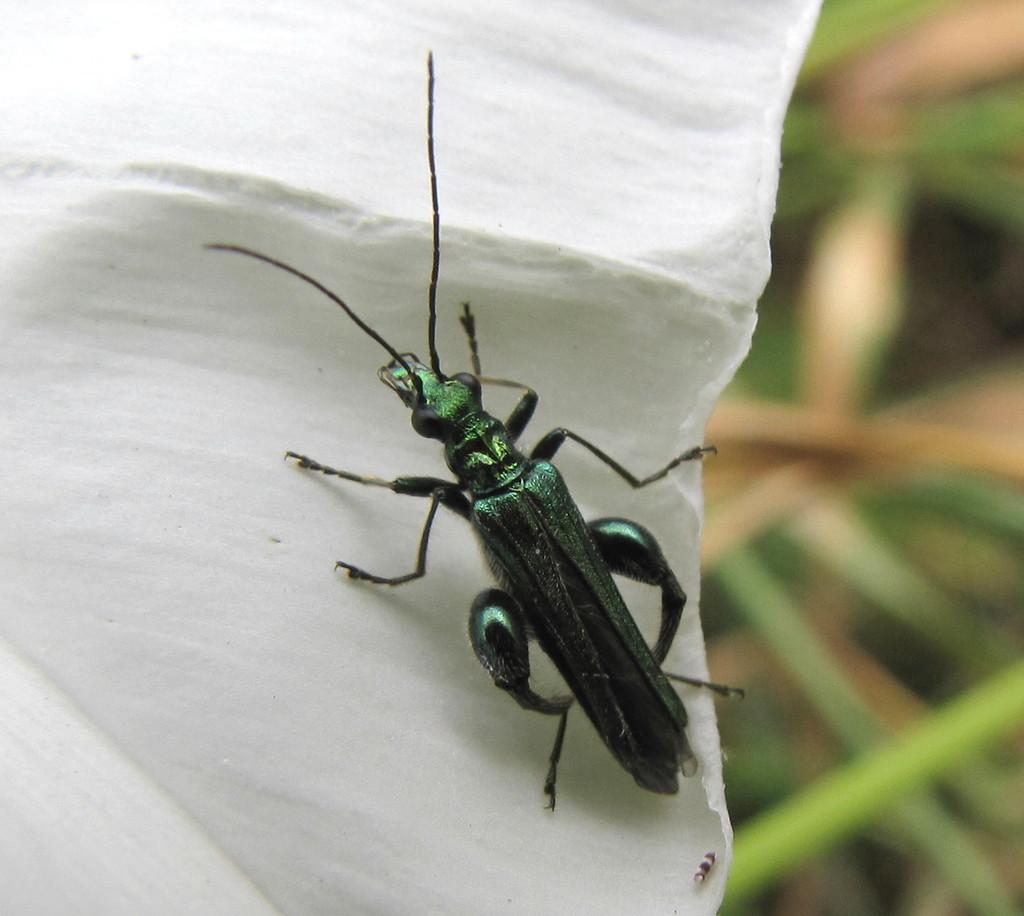What type of creature can be seen in the image? There is an insect in the image. What is the temperature of the sugar on the coast in the image? There is no sugar or coast present in the image; it only features an insect. 